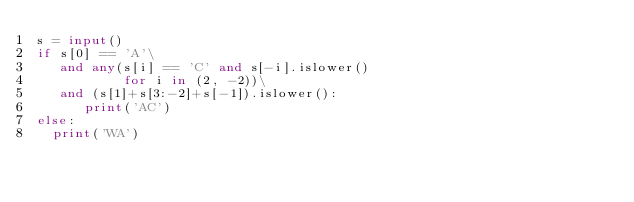<code> <loc_0><loc_0><loc_500><loc_500><_Python_>s = input()
if s[0] == 'A'\
   and any(s[i] == 'C' and s[-i].islower()
       	   for i in (2, -2))\
   and (s[1]+s[3:-2]+s[-1]).islower():
      print('AC')
else:
  print('WA')
</code> 